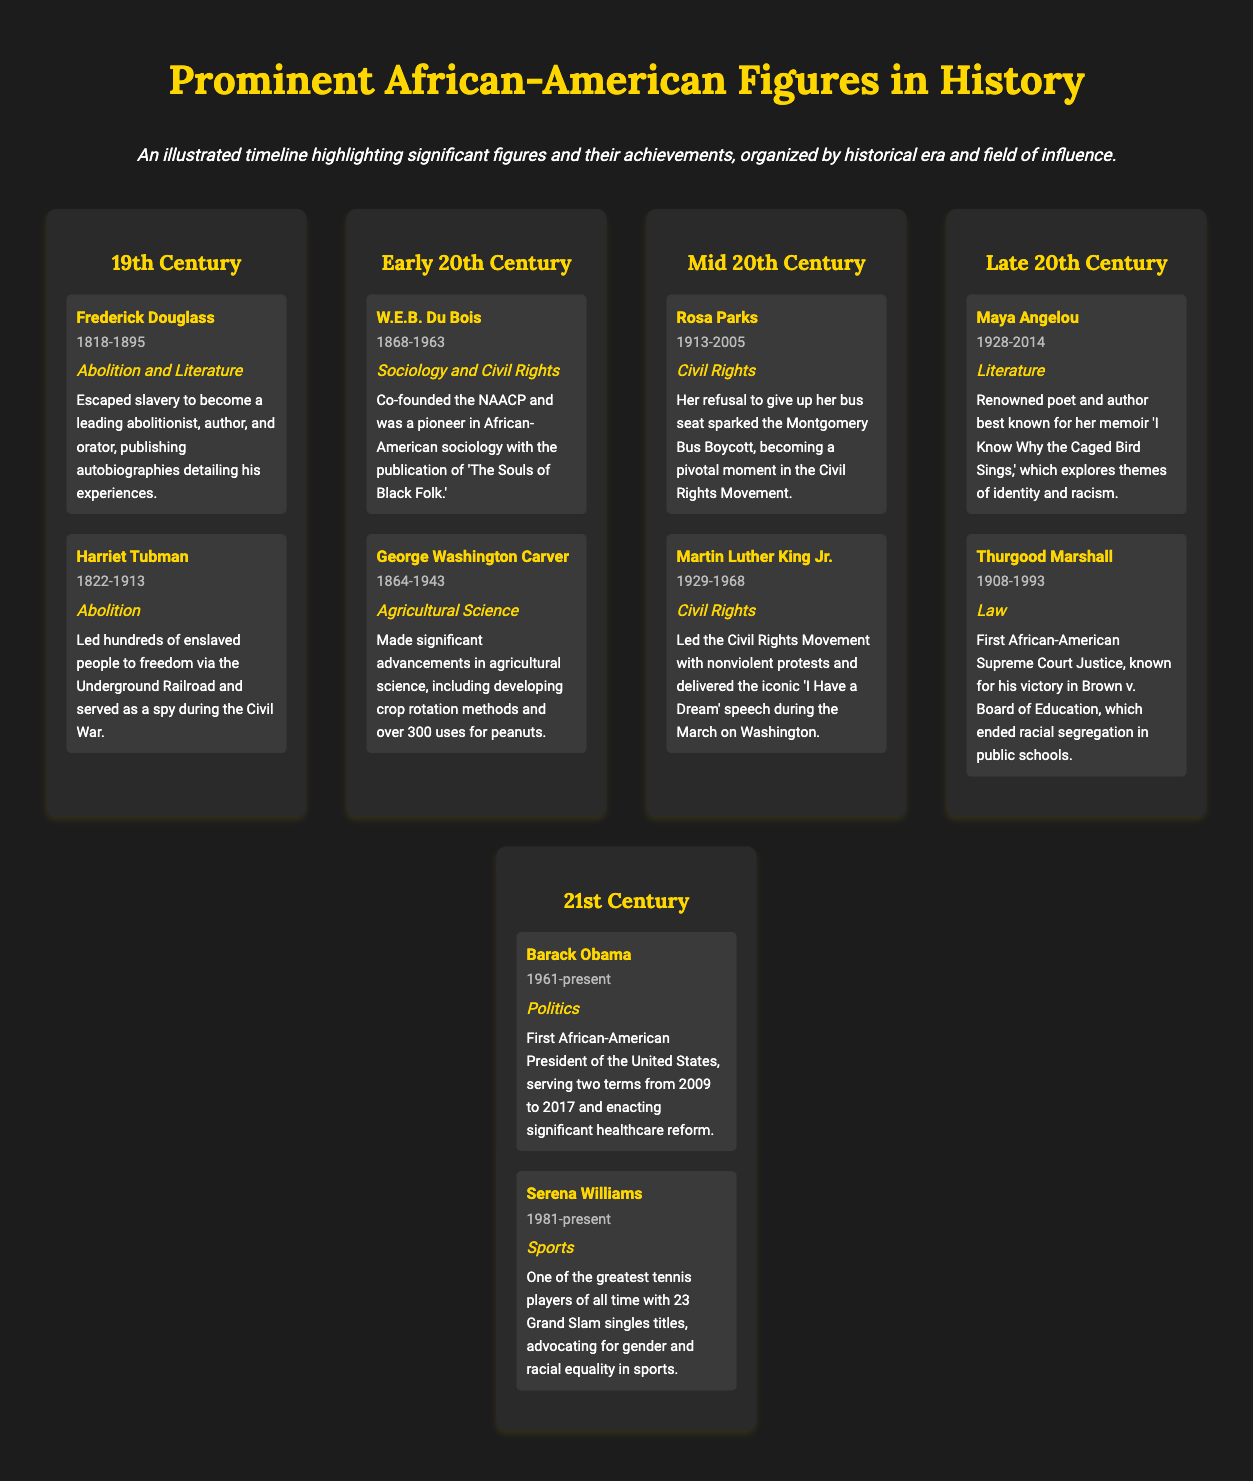What years did Frederick Douglass live? The document lists Frederick Douglass's lifespan as 1818-1895.
Answer: 1818-1895 What field did Harriet Tubman influence? The document states that Harriet Tubman is noted for her influence in the field of Abolition.
Answer: Abolition Who co-founded the NAACP? The document mentions W.E.B. Du Bois as the co-founder of the NAACP.
Answer: W.E.B. Du Bois Which figure is known for their work in Agricultural Science? According to the document, George Washington Carver is recognized for his contributions in Agricultural Science.
Answer: George Washington Carver What significant event did Rosa Parks' action initiate? The document explains that Rosa Parks' refusal sparked the Montgomery Bus Boycott.
Answer: Montgomery Bus Boycott Which literary work is Maya Angelou best known for? The document indicates that Maya Angelou is best known for her memoir 'I Know Why the Caged Bird Sings.'
Answer: 'I Know Why the Caged Bird Sings' Who was the first African-American Supreme Court Justice? The document states that Thurgood Marshall was the first African-American Supreme Court Justice.
Answer: Thurgood Marshall How many Grand Slam singles titles does Serena Williams have? The document specifies that Serena Williams has 23 Grand Slam singles titles.
Answer: 23 In which century did Barack Obama serve as President? The document indicates that Barack Obama served as President in the 21st Century.
Answer: 21st Century 